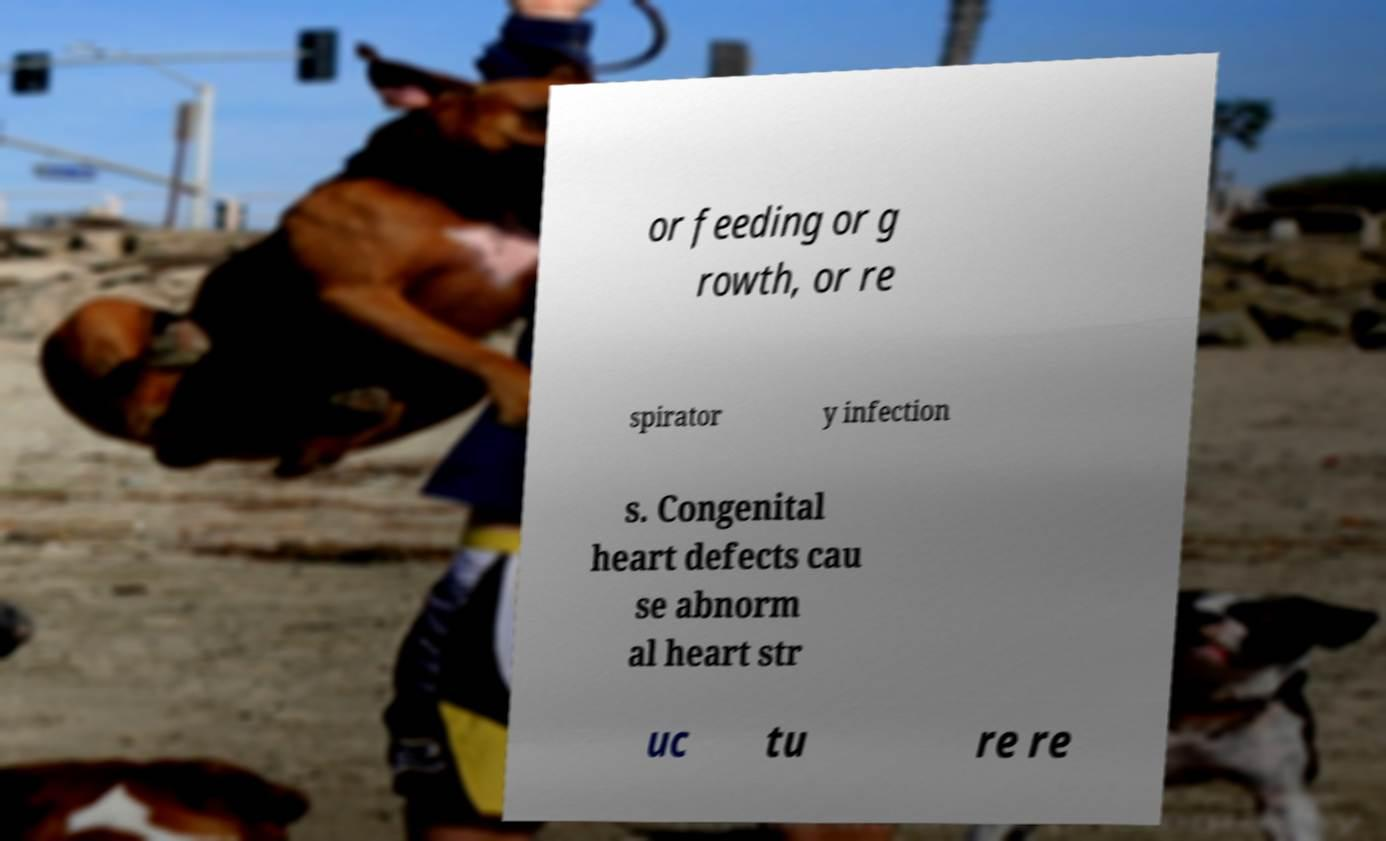For documentation purposes, I need the text within this image transcribed. Could you provide that? or feeding or g rowth, or re spirator y infection s. Congenital heart defects cau se abnorm al heart str uc tu re re 